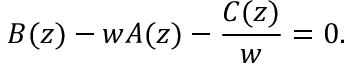<formula> <loc_0><loc_0><loc_500><loc_500>B ( z ) - w A ( z ) - \frac { C ( z ) } { w } = 0 .</formula> 